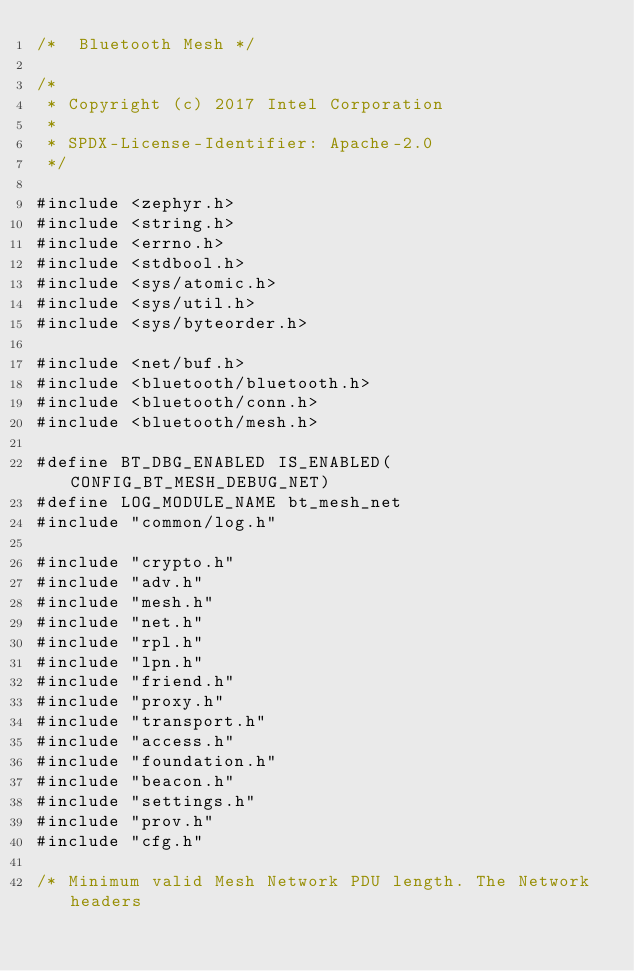<code> <loc_0><loc_0><loc_500><loc_500><_C_>/*  Bluetooth Mesh */

/*
 * Copyright (c) 2017 Intel Corporation
 *
 * SPDX-License-Identifier: Apache-2.0
 */

#include <zephyr.h>
#include <string.h>
#include <errno.h>
#include <stdbool.h>
#include <sys/atomic.h>
#include <sys/util.h>
#include <sys/byteorder.h>

#include <net/buf.h>
#include <bluetooth/bluetooth.h>
#include <bluetooth/conn.h>
#include <bluetooth/mesh.h>

#define BT_DBG_ENABLED IS_ENABLED(CONFIG_BT_MESH_DEBUG_NET)
#define LOG_MODULE_NAME bt_mesh_net
#include "common/log.h"

#include "crypto.h"
#include "adv.h"
#include "mesh.h"
#include "net.h"
#include "rpl.h"
#include "lpn.h"
#include "friend.h"
#include "proxy.h"
#include "transport.h"
#include "access.h"
#include "foundation.h"
#include "beacon.h"
#include "settings.h"
#include "prov.h"
#include "cfg.h"

/* Minimum valid Mesh Network PDU length. The Network headers</code> 